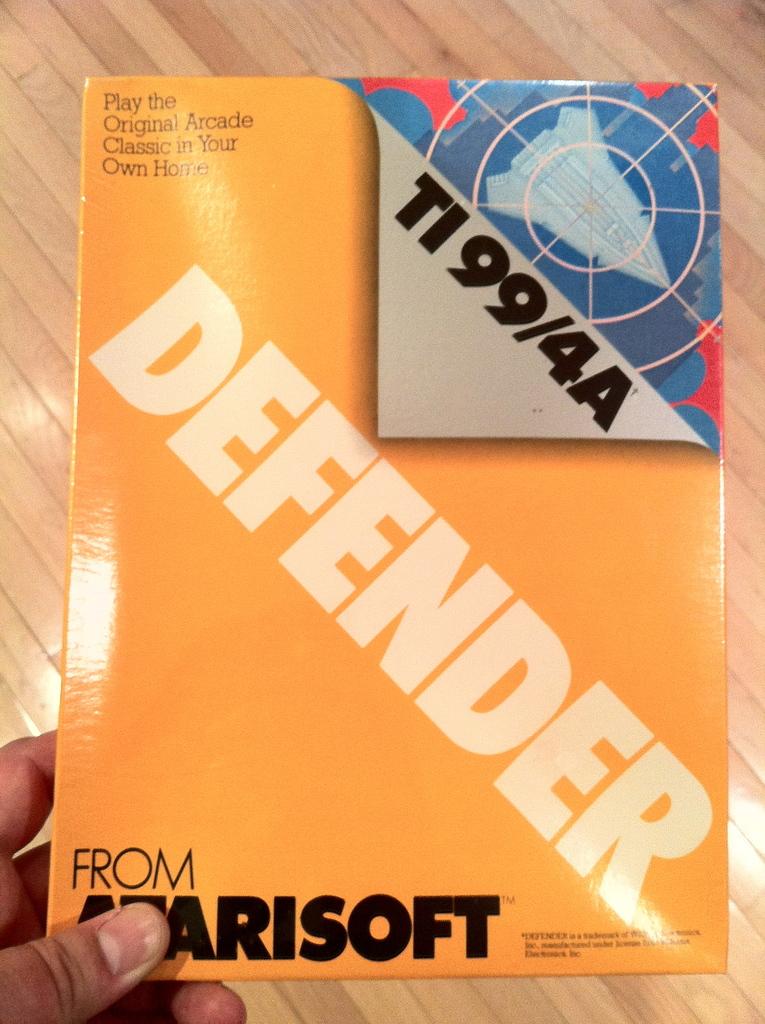What does this book help you do?
Make the answer very short. Play the original arcade classic in your own home. What is the title of this game?
Keep it short and to the point. Defender. 